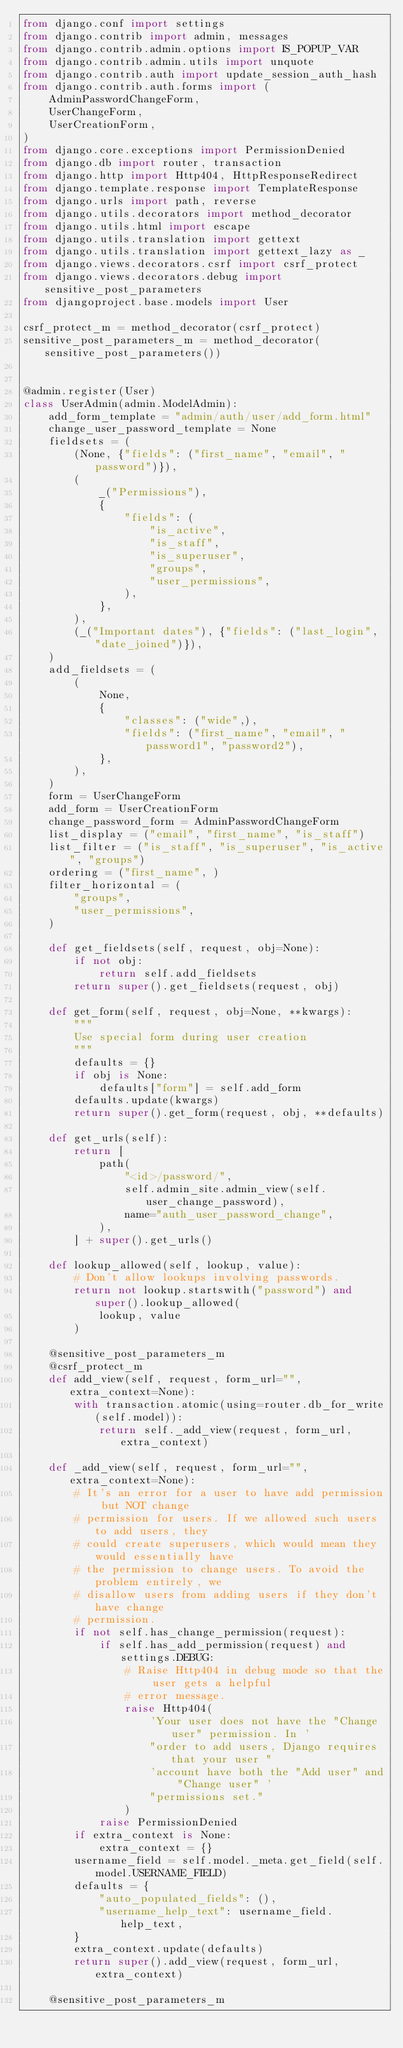<code> <loc_0><loc_0><loc_500><loc_500><_Python_>from django.conf import settings
from django.contrib import admin, messages
from django.contrib.admin.options import IS_POPUP_VAR
from django.contrib.admin.utils import unquote
from django.contrib.auth import update_session_auth_hash
from django.contrib.auth.forms import (
    AdminPasswordChangeForm,
    UserChangeForm,
    UserCreationForm,
)
from django.core.exceptions import PermissionDenied
from django.db import router, transaction
from django.http import Http404, HttpResponseRedirect
from django.template.response import TemplateResponse
from django.urls import path, reverse
from django.utils.decorators import method_decorator
from django.utils.html import escape
from django.utils.translation import gettext
from django.utils.translation import gettext_lazy as _
from django.views.decorators.csrf import csrf_protect
from django.views.decorators.debug import sensitive_post_parameters
from djangoproject.base.models import User

csrf_protect_m = method_decorator(csrf_protect)
sensitive_post_parameters_m = method_decorator(sensitive_post_parameters())


@admin.register(User)
class UserAdmin(admin.ModelAdmin):
    add_form_template = "admin/auth/user/add_form.html"
    change_user_password_template = None
    fieldsets = (
        (None, {"fields": ("first_name", "email", "password")}),
        (
            _("Permissions"),
            {
                "fields": (
                    "is_active",
                    "is_staff",
                    "is_superuser",
                    "groups",
                    "user_permissions",
                ),
            },
        ),
        (_("Important dates"), {"fields": ("last_login", "date_joined")}),
    )
    add_fieldsets = (
        (
            None,
            {
                "classes": ("wide",),
                "fields": ("first_name", "email", "password1", "password2"),
            },
        ),
    )
    form = UserChangeForm
    add_form = UserCreationForm
    change_password_form = AdminPasswordChangeForm
    list_display = ("email", "first_name", "is_staff")
    list_filter = ("is_staff", "is_superuser", "is_active", "groups")
    ordering = ("first_name", )
    filter_horizontal = (
        "groups",
        "user_permissions",
    )

    def get_fieldsets(self, request, obj=None):
        if not obj:
            return self.add_fieldsets
        return super().get_fieldsets(request, obj)

    def get_form(self, request, obj=None, **kwargs):
        """
        Use special form during user creation
        """
        defaults = {}
        if obj is None:
            defaults["form"] = self.add_form
        defaults.update(kwargs)
        return super().get_form(request, obj, **defaults)

    def get_urls(self):
        return [
            path(
                "<id>/password/",
                self.admin_site.admin_view(self.user_change_password),
                name="auth_user_password_change",
            ),
        ] + super().get_urls()

    def lookup_allowed(self, lookup, value):
        # Don't allow lookups involving passwords.
        return not lookup.startswith("password") and super().lookup_allowed(
            lookup, value
        )

    @sensitive_post_parameters_m
    @csrf_protect_m
    def add_view(self, request, form_url="", extra_context=None):
        with transaction.atomic(using=router.db_for_write(self.model)):
            return self._add_view(request, form_url, extra_context)

    def _add_view(self, request, form_url="", extra_context=None):
        # It's an error for a user to have add permission but NOT change
        # permission for users. If we allowed such users to add users, they
        # could create superusers, which would mean they would essentially have
        # the permission to change users. To avoid the problem entirely, we
        # disallow users from adding users if they don't have change
        # permission.
        if not self.has_change_permission(request):
            if self.has_add_permission(request) and settings.DEBUG:
                # Raise Http404 in debug mode so that the user gets a helpful
                # error message.
                raise Http404(
                    'Your user does not have the "Change user" permission. In '
                    "order to add users, Django requires that your user "
                    'account have both the "Add user" and "Change user" '
                    "permissions set."
                )
            raise PermissionDenied
        if extra_context is None:
            extra_context = {}
        username_field = self.model._meta.get_field(self.model.USERNAME_FIELD)
        defaults = {
            "auto_populated_fields": (),
            "username_help_text": username_field.help_text,
        }
        extra_context.update(defaults)
        return super().add_view(request, form_url, extra_context)

    @sensitive_post_parameters_m</code> 